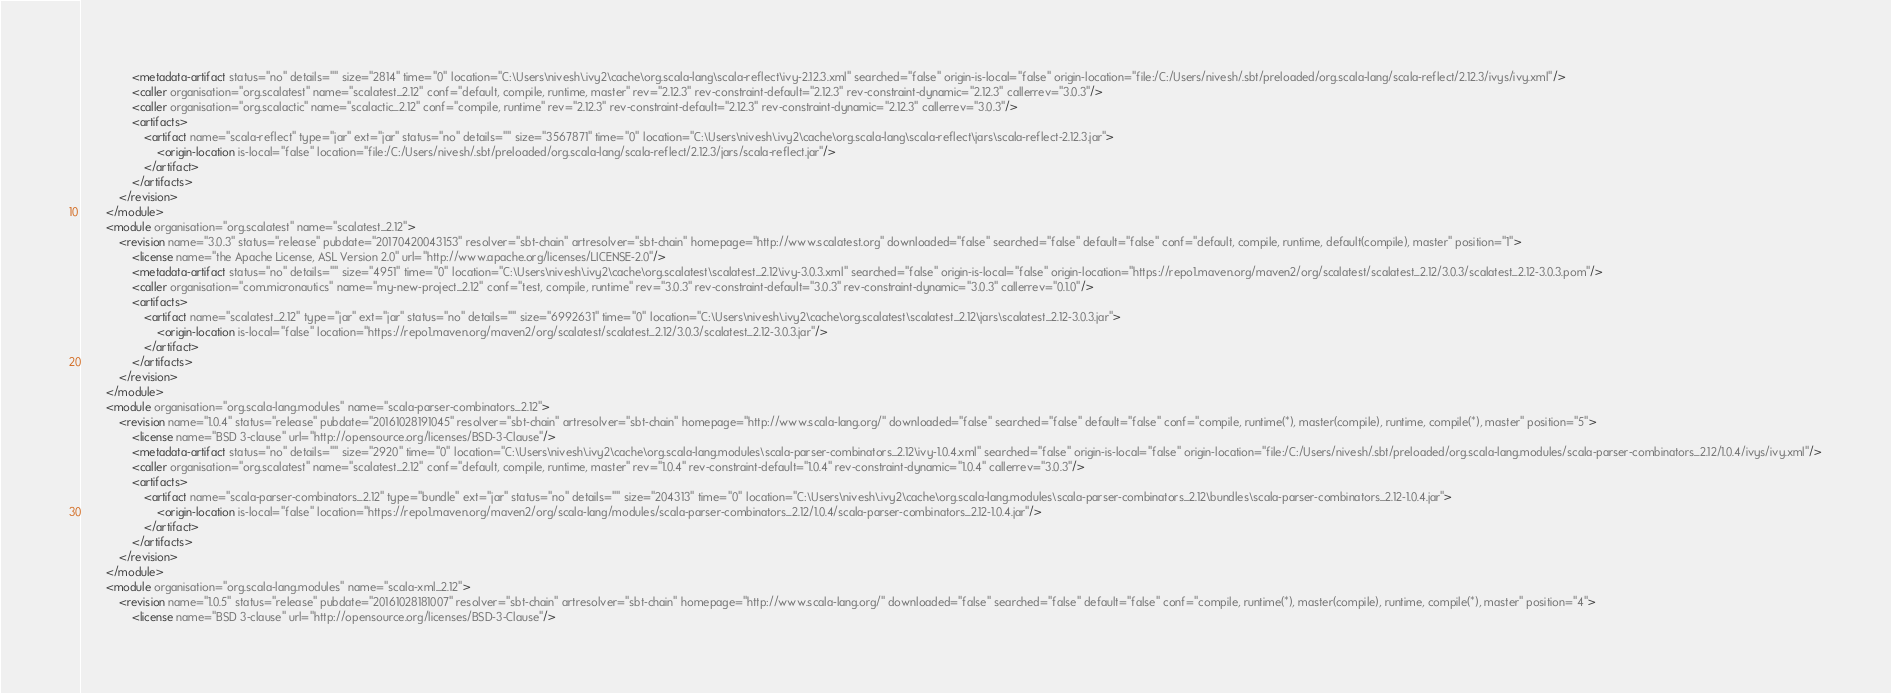Convert code to text. <code><loc_0><loc_0><loc_500><loc_500><_XML_>				<metadata-artifact status="no" details="" size="2814" time="0" location="C:\Users\nivesh\.ivy2\cache\org.scala-lang\scala-reflect\ivy-2.12.3.xml" searched="false" origin-is-local="false" origin-location="file:/C:/Users/nivesh/.sbt/preloaded/org.scala-lang/scala-reflect/2.12.3/ivys/ivy.xml"/>
				<caller organisation="org.scalatest" name="scalatest_2.12" conf="default, compile, runtime, master" rev="2.12.3" rev-constraint-default="2.12.3" rev-constraint-dynamic="2.12.3" callerrev="3.0.3"/>
				<caller organisation="org.scalactic" name="scalactic_2.12" conf="compile, runtime" rev="2.12.3" rev-constraint-default="2.12.3" rev-constraint-dynamic="2.12.3" callerrev="3.0.3"/>
				<artifacts>
					<artifact name="scala-reflect" type="jar" ext="jar" status="no" details="" size="3567871" time="0" location="C:\Users\nivesh\.ivy2\cache\org.scala-lang\scala-reflect\jars\scala-reflect-2.12.3.jar">
						<origin-location is-local="false" location="file:/C:/Users/nivesh/.sbt/preloaded/org.scala-lang/scala-reflect/2.12.3/jars/scala-reflect.jar"/>
					</artifact>
				</artifacts>
			</revision>
		</module>
		<module organisation="org.scalatest" name="scalatest_2.12">
			<revision name="3.0.3" status="release" pubdate="20170420043153" resolver="sbt-chain" artresolver="sbt-chain" homepage="http://www.scalatest.org" downloaded="false" searched="false" default="false" conf="default, compile, runtime, default(compile), master" position="1">
				<license name="the Apache License, ASL Version 2.0" url="http://www.apache.org/licenses/LICENSE-2.0"/>
				<metadata-artifact status="no" details="" size="4951" time="0" location="C:\Users\nivesh\.ivy2\cache\org.scalatest\scalatest_2.12\ivy-3.0.3.xml" searched="false" origin-is-local="false" origin-location="https://repo1.maven.org/maven2/org/scalatest/scalatest_2.12/3.0.3/scalatest_2.12-3.0.3.pom"/>
				<caller organisation="com.micronautics" name="my-new-project_2.12" conf="test, compile, runtime" rev="3.0.3" rev-constraint-default="3.0.3" rev-constraint-dynamic="3.0.3" callerrev="0.1.0"/>
				<artifacts>
					<artifact name="scalatest_2.12" type="jar" ext="jar" status="no" details="" size="6992631" time="0" location="C:\Users\nivesh\.ivy2\cache\org.scalatest\scalatest_2.12\jars\scalatest_2.12-3.0.3.jar">
						<origin-location is-local="false" location="https://repo1.maven.org/maven2/org/scalatest/scalatest_2.12/3.0.3/scalatest_2.12-3.0.3.jar"/>
					</artifact>
				</artifacts>
			</revision>
		</module>
		<module organisation="org.scala-lang.modules" name="scala-parser-combinators_2.12">
			<revision name="1.0.4" status="release" pubdate="20161028191045" resolver="sbt-chain" artresolver="sbt-chain" homepage="http://www.scala-lang.org/" downloaded="false" searched="false" default="false" conf="compile, runtime(*), master(compile), runtime, compile(*), master" position="5">
				<license name="BSD 3-clause" url="http://opensource.org/licenses/BSD-3-Clause"/>
				<metadata-artifact status="no" details="" size="2920" time="0" location="C:\Users\nivesh\.ivy2\cache\org.scala-lang.modules\scala-parser-combinators_2.12\ivy-1.0.4.xml" searched="false" origin-is-local="false" origin-location="file:/C:/Users/nivesh/.sbt/preloaded/org.scala-lang.modules/scala-parser-combinators_2.12/1.0.4/ivys/ivy.xml"/>
				<caller organisation="org.scalatest" name="scalatest_2.12" conf="default, compile, runtime, master" rev="1.0.4" rev-constraint-default="1.0.4" rev-constraint-dynamic="1.0.4" callerrev="3.0.3"/>
				<artifacts>
					<artifact name="scala-parser-combinators_2.12" type="bundle" ext="jar" status="no" details="" size="204313" time="0" location="C:\Users\nivesh\.ivy2\cache\org.scala-lang.modules\scala-parser-combinators_2.12\bundles\scala-parser-combinators_2.12-1.0.4.jar">
						<origin-location is-local="false" location="https://repo1.maven.org/maven2/org/scala-lang/modules/scala-parser-combinators_2.12/1.0.4/scala-parser-combinators_2.12-1.0.4.jar"/>
					</artifact>
				</artifacts>
			</revision>
		</module>
		<module organisation="org.scala-lang.modules" name="scala-xml_2.12">
			<revision name="1.0.5" status="release" pubdate="20161028181007" resolver="sbt-chain" artresolver="sbt-chain" homepage="http://www.scala-lang.org/" downloaded="false" searched="false" default="false" conf="compile, runtime(*), master(compile), runtime, compile(*), master" position="4">
				<license name="BSD 3-clause" url="http://opensource.org/licenses/BSD-3-Clause"/></code> 